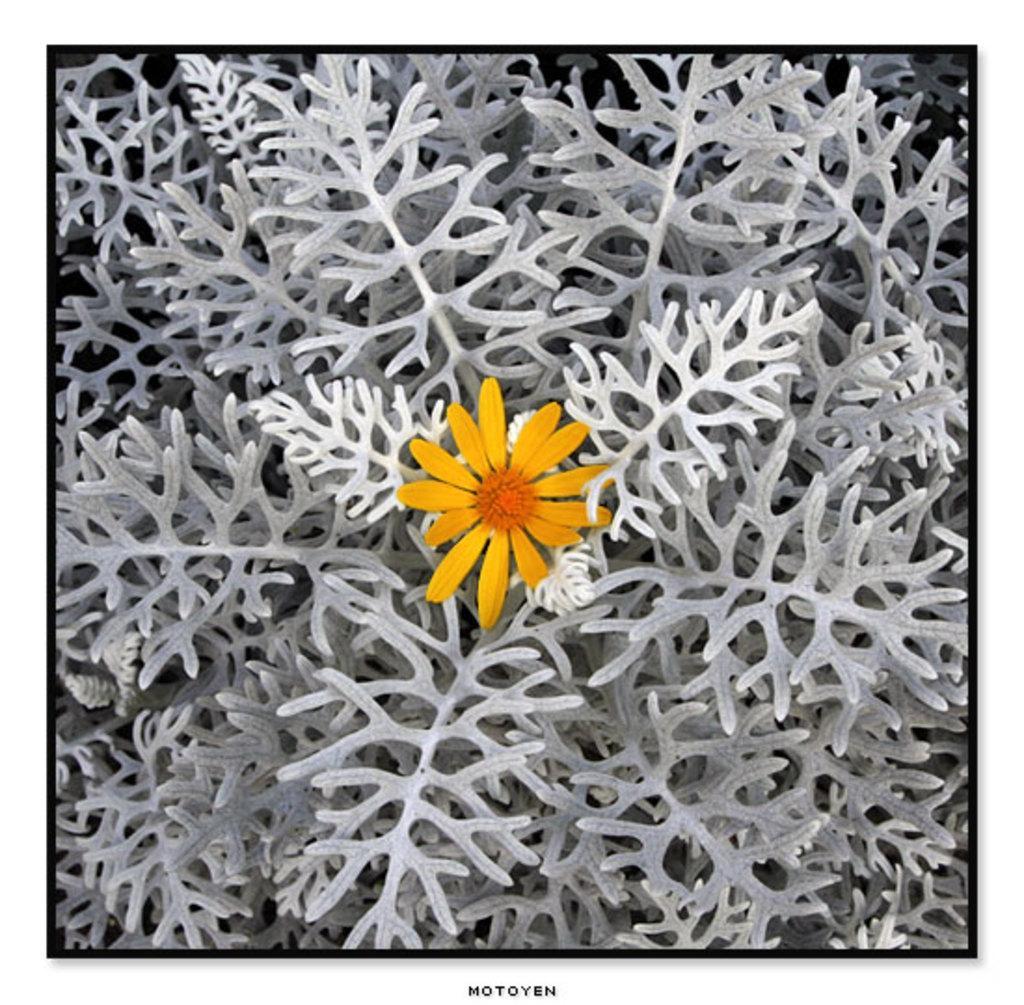Please provide a concise description of this image. In this image we can see edited picture of a flower on a plant. At the bottom of the image we can see some text. 